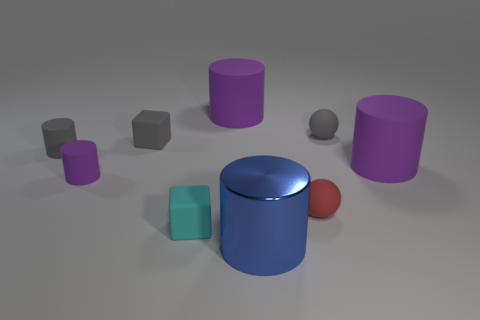Subtract all gray spheres. How many purple cylinders are left? 3 Subtract all blue cylinders. How many cylinders are left? 4 Subtract all small purple cylinders. How many cylinders are left? 4 Add 1 tiny purple rubber balls. How many objects exist? 10 Subtract all green cylinders. Subtract all yellow cubes. How many cylinders are left? 5 Subtract all blocks. How many objects are left? 7 Add 7 tiny red balls. How many tiny red balls exist? 8 Subtract 0 brown cubes. How many objects are left? 9 Subtract all small matte balls. Subtract all tiny gray spheres. How many objects are left? 6 Add 7 big blue metal cylinders. How many big blue metal cylinders are left? 8 